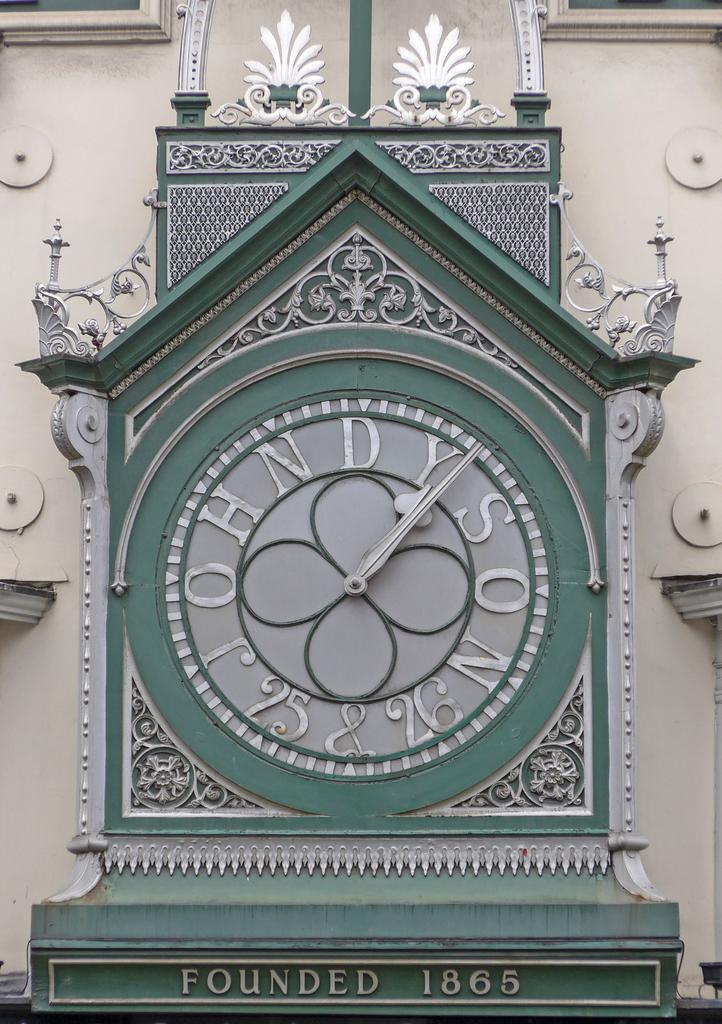<image>
Share a concise interpretation of the image provided. A clock that says John Dyson 25 & 26 on the face of it. 